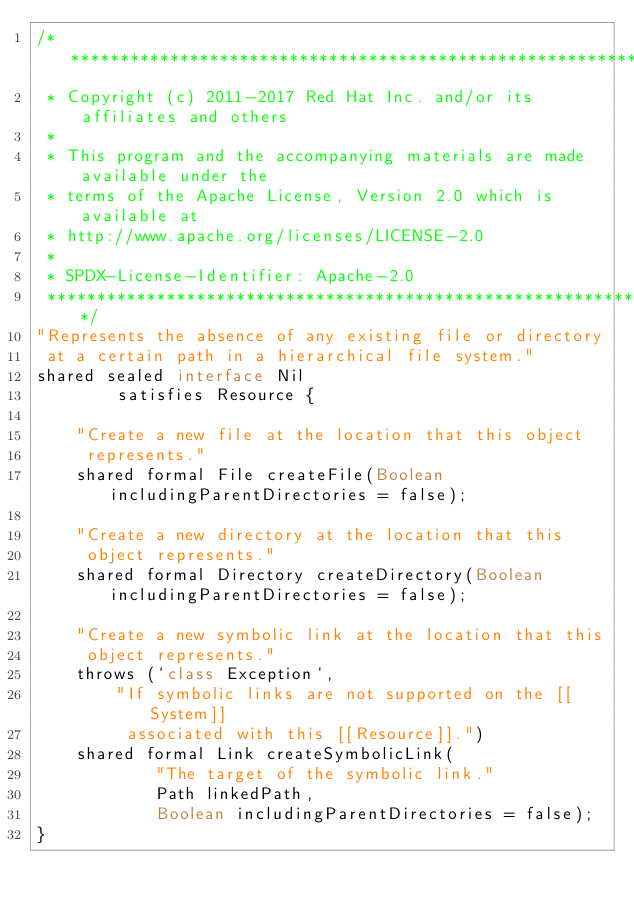Convert code to text. <code><loc_0><loc_0><loc_500><loc_500><_Ceylon_>/********************************************************************************
 * Copyright (c) 2011-2017 Red Hat Inc. and/or its affiliates and others
 *
 * This program and the accompanying materials are made available under the 
 * terms of the Apache License, Version 2.0 which is available at
 * http://www.apache.org/licenses/LICENSE-2.0
 *
 * SPDX-License-Identifier: Apache-2.0 
 ********************************************************************************/
"Represents the absence of any existing file or directory 
 at a certain path in a hierarchical file system."
shared sealed interface Nil 
        satisfies Resource {
    
    "Create a new file at the location that this object
     represents."
    shared formal File createFile(Boolean includingParentDirectories = false);
    
    "Create a new directory at the location that this 
     object represents."
    shared formal Directory createDirectory(Boolean includingParentDirectories = false);
    
    "Create a new symbolic link at the location that this
     object represents."
    throws (`class Exception`,
        "If symbolic links are not supported on the [[System]]
         associated with this [[Resource]].")
    shared formal Link createSymbolicLink(
            "The target of the symbolic link."
            Path linkedPath,
            Boolean includingParentDirectories = false);
}
</code> 